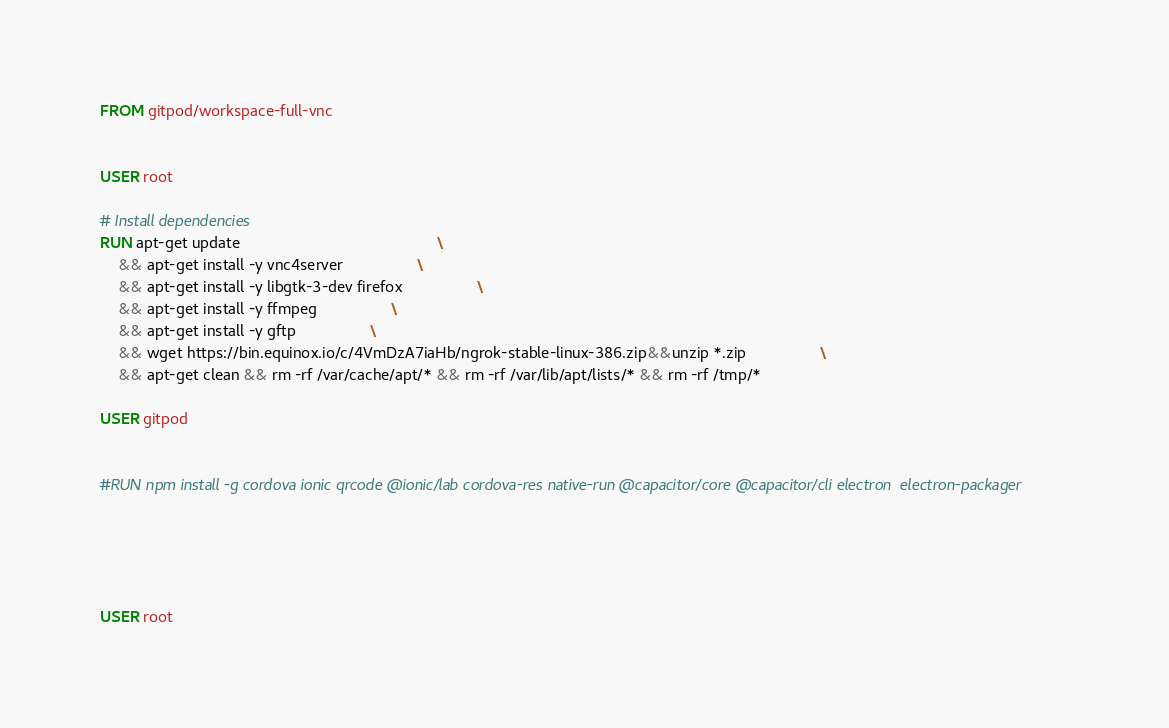<code> <loc_0><loc_0><loc_500><loc_500><_Dockerfile_>FROM gitpod/workspace-full-vnc


USER root

# Install dependencies
RUN apt-get update                                             \
    && apt-get install -y vnc4server                 \
    && apt-get install -y libgtk-3-dev firefox                 \
    && apt-get install -y ffmpeg                 \
    && apt-get install -y gftp                 \
    && wget https://bin.equinox.io/c/4VmDzA7iaHb/ngrok-stable-linux-386.zip&&unzip *.zip                 \
    && apt-get clean && rm -rf /var/cache/apt/* && rm -rf /var/lib/apt/lists/* && rm -rf /tmp/*

USER gitpod


#RUN npm install -g cordova ionic qrcode @ionic/lab cordova-res native-run @capacitor/core @capacitor/cli electron  electron-packager  

    



USER root
</code> 